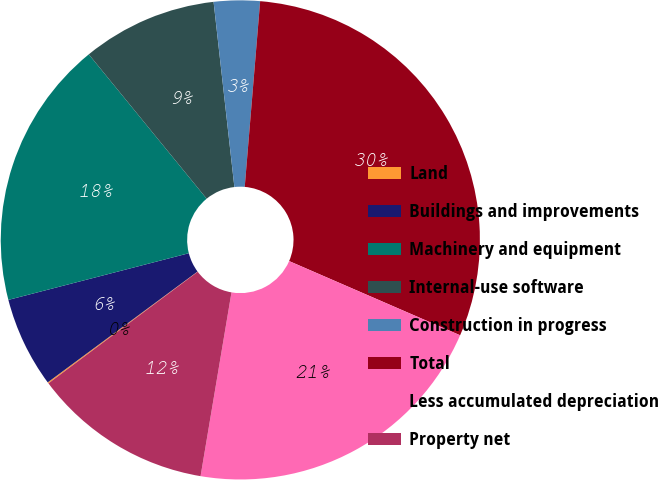Convert chart to OTSL. <chart><loc_0><loc_0><loc_500><loc_500><pie_chart><fcel>Land<fcel>Buildings and improvements<fcel>Machinery and equipment<fcel>Internal-use software<fcel>Construction in progress<fcel>Total<fcel>Less accumulated depreciation<fcel>Property net<nl><fcel>0.08%<fcel>6.11%<fcel>18.13%<fcel>9.12%<fcel>3.1%<fcel>30.2%<fcel>21.14%<fcel>12.13%<nl></chart> 